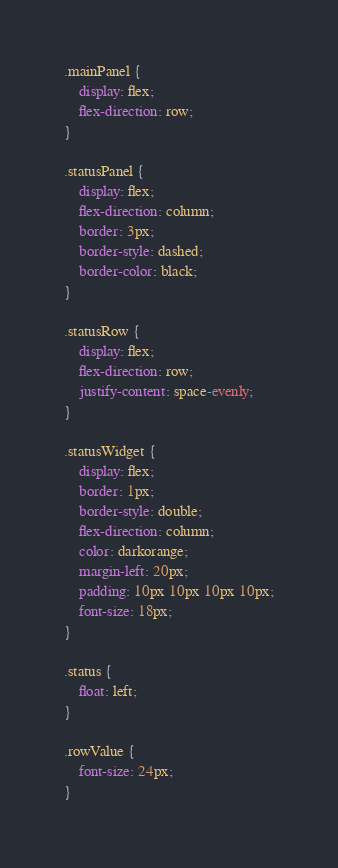Convert code to text. <code><loc_0><loc_0><loc_500><loc_500><_CSS_>.mainPanel {
    display: flex;
    flex-direction: row;
}

.statusPanel {
    display: flex;
    flex-direction: column;
    border: 3px;
    border-style: dashed;
    border-color: black;
}

.statusRow {
    display: flex;
    flex-direction: row;
    justify-content: space-evenly;
}

.statusWidget {
    display: flex;
    border: 1px;
    border-style: double;
    flex-direction: column;
    color: darkorange;
    margin-left: 20px;
    padding: 10px 10px 10px 10px;
    font-size: 18px;
}

.status {
    float: left;
}

.rowValue {
    font-size: 24px;
}
</code> 